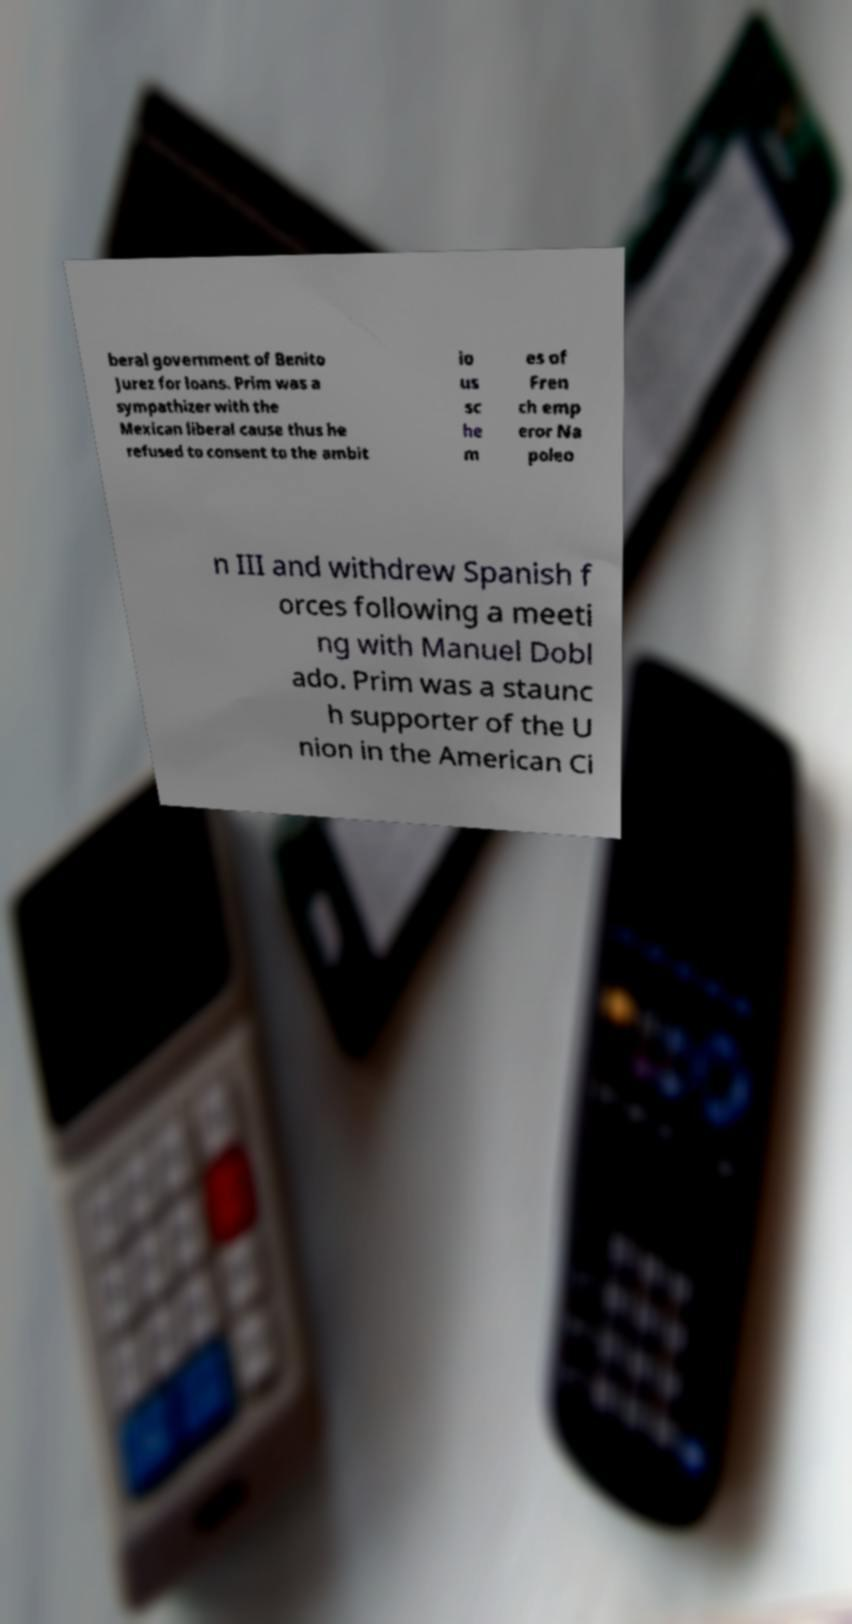Please read and relay the text visible in this image. What does it say? beral government of Benito Jurez for loans. Prim was a sympathizer with the Mexican liberal cause thus he refused to consent to the ambit io us sc he m es of Fren ch emp eror Na poleo n III and withdrew Spanish f orces following a meeti ng with Manuel Dobl ado. Prim was a staunc h supporter of the U nion in the American Ci 